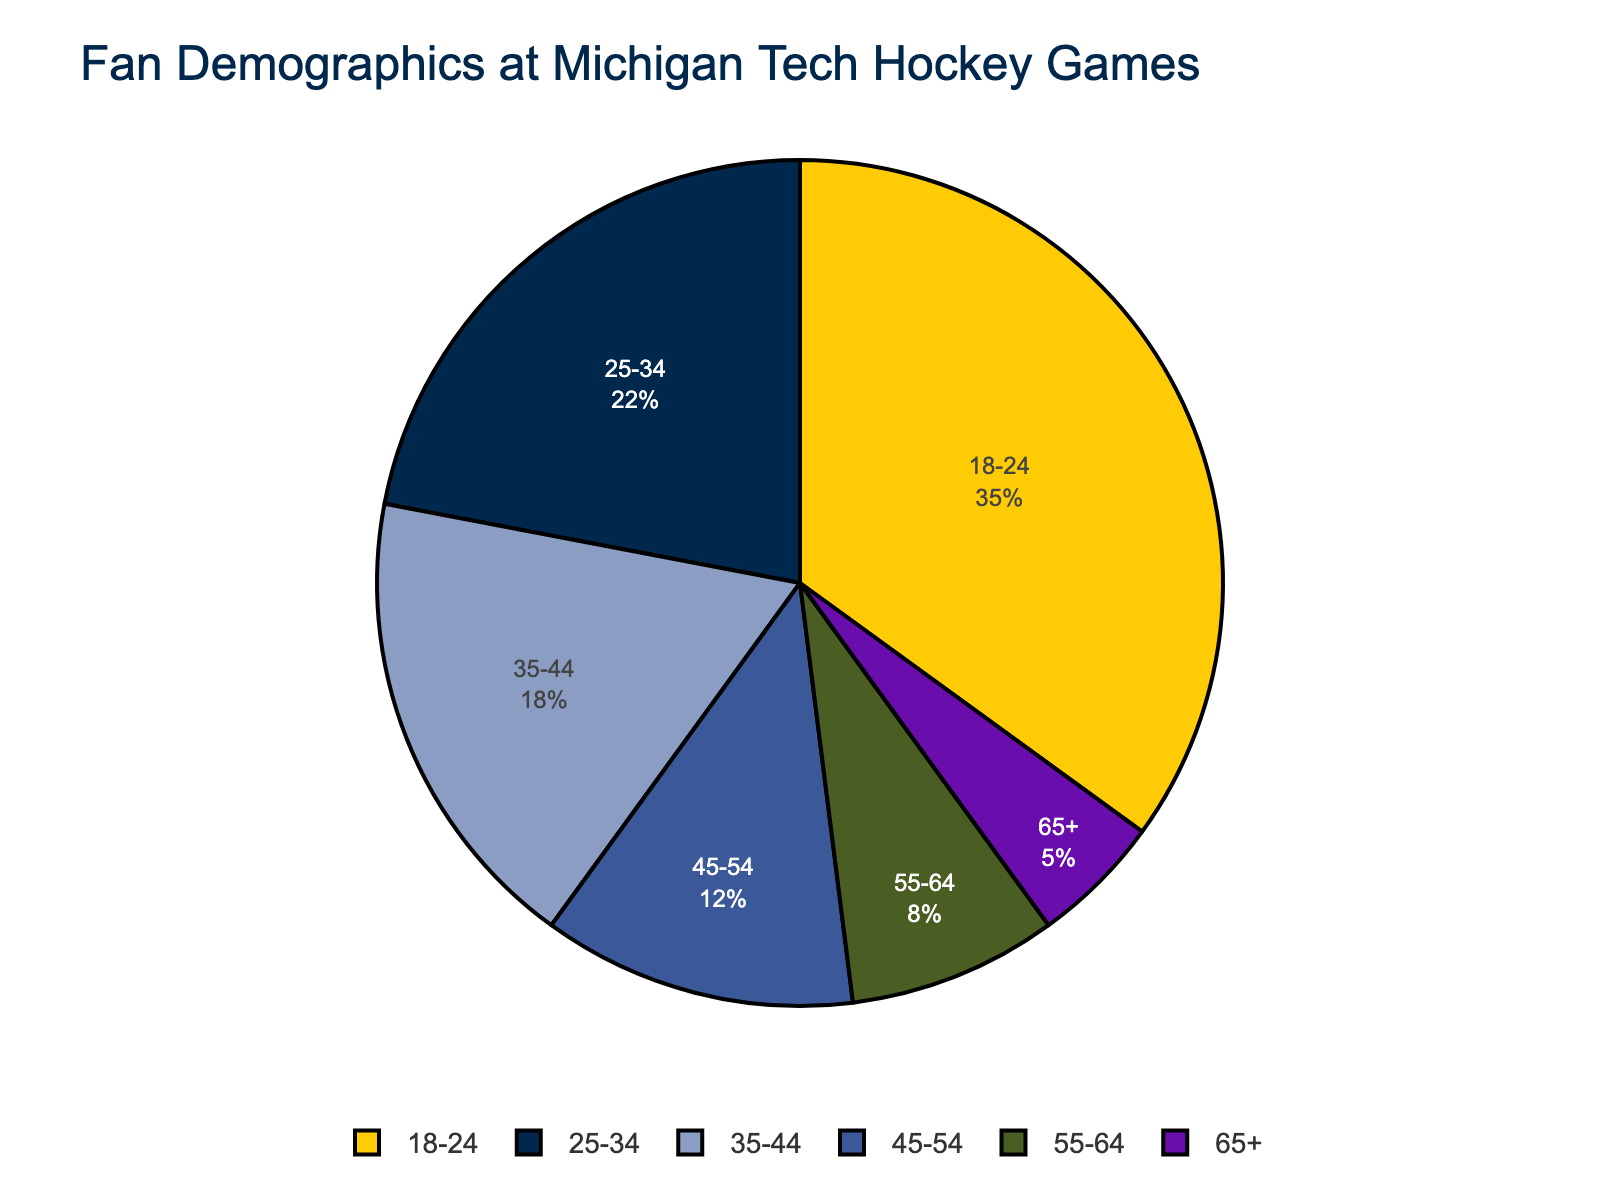What age group makes up the highest percentage of fans at Michigan Tech hockey games? The age group with the highest percentage is the one with the largest segment in the pie chart. Here, 18-24 is the largest segment, denoted as 35%.
Answer: 18-24 What is the total percentage of fans aged 25-34 and 35-44 combined? Add the percentages of fans aged 25-34 (22%) and 35-44 (18%). 22 + 18 = 40.
Answer: 40% Which age group comprises the least percentage of fans? The age group with the smallest segment in the pie chart is 65+, indicated as 5%.
Answer: 65+ How many age groups make up more than 20% of the fanbase? The age groups with more than 20% are those whose percentages exceed 20%. Here, only one age group, 18-24, has 35%, which is more than 20%.
Answer: 1 Which color represents the age group of 45-54, and what percentage does this age group comprise? The age group 45-54 is represented by the green segment in the chart, which constitutes 12%.
Answer: Green, 12% What is the difference between the largest and smallest fanbase age groups? Subtract the percentage of the smallest age group (65+ with 5%) from the largest age group (18-24 with 35%). 35 - 5 = 30.
Answer: 30% Are there more fans in the 25-34 age group or the 45-54 age group? Compare the percentages for the 25-34 group (22%) and the 45-54 group (12%). Since 22% is more than 12%, the 25-34 group has more fans.
Answer: 25-34 What percentage of fans are aged 55 and older? Add the percentages for age groups 55-64 (8%) and 65+ (5%). 8 + 5 = 13.
Answer: 13% What proportion of the fanbase is composed of fans aged 35-54? Add the percentages for age groups 35-44 (18%) and 45-54 (12%). 18 + 12 = 30.
Answer: 30% Is there any age group with a fanbase between 5% and 10%? Examine the percentages and identify which fall between 5% and 10%. Only the 55-64 age group falls in this range with 8%.
Answer: Yes, 55-64 